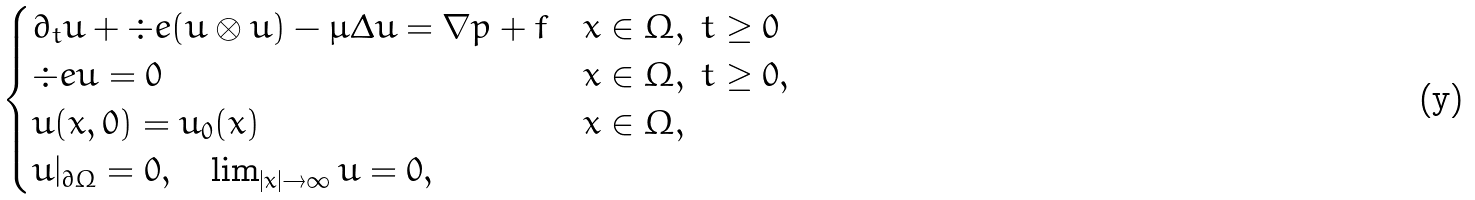<formula> <loc_0><loc_0><loc_500><loc_500>\begin{cases} \partial _ { t } u + \div e ( u \otimes u ) - \mu \Delta u = \nabla p + f & x \in \Omega , \ t \geq 0 \\ \div e u = 0 & x \in \Omega , \ t \geq 0 , \\ u ( x , 0 ) = u _ { 0 } ( x ) & x \in \Omega , \\ u | _ { \partial \Omega } = 0 , \quad \lim _ { | x | \to \infty } u = 0 , \end{cases}</formula> 